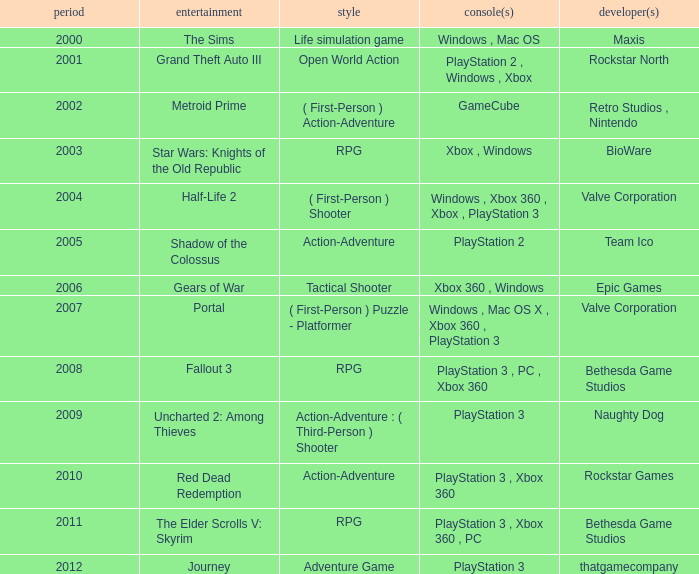What's the genre of The Sims before 2002? Life simulation game. 